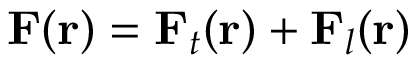Convert formula to latex. <formula><loc_0><loc_0><loc_500><loc_500>F ( r ) = F _ { t } ( r ) + F _ { l } ( r )</formula> 